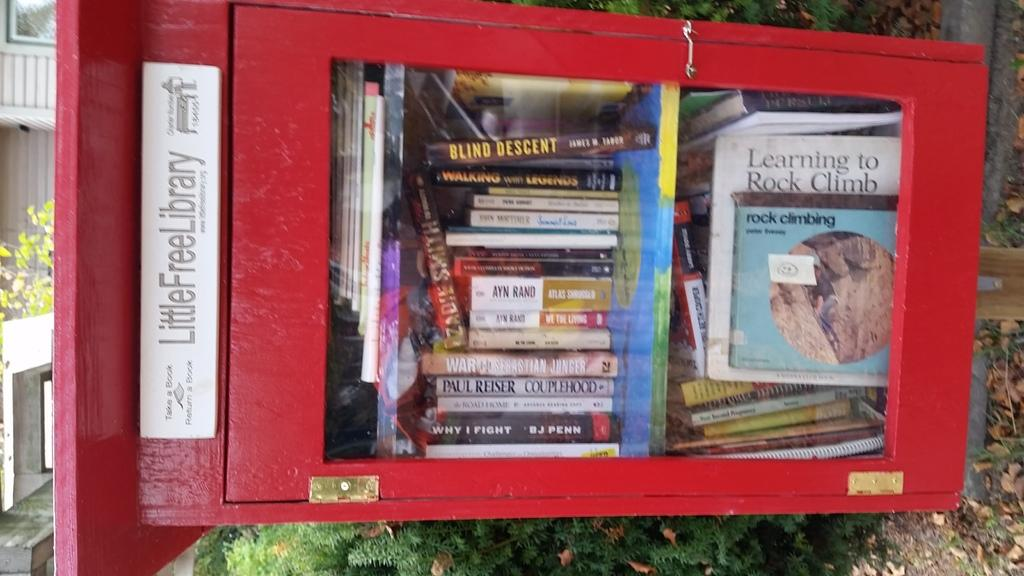<image>
Write a terse but informative summary of the picture. A red box labeled Litter Free Library with books in it. 